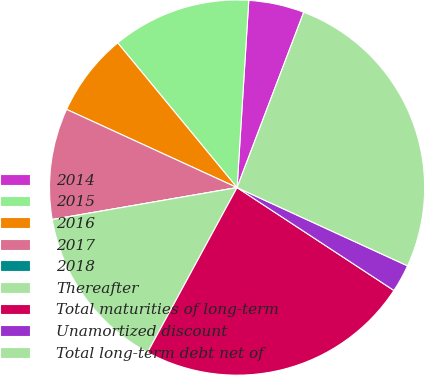Convert chart to OTSL. <chart><loc_0><loc_0><loc_500><loc_500><pie_chart><fcel>2014<fcel>2015<fcel>2016<fcel>2017<fcel>2018<fcel>Thereafter<fcel>Total maturities of long-term<fcel>Unamortized discount<fcel>Total long-term debt net of<nl><fcel>4.79%<fcel>11.97%<fcel>7.18%<fcel>9.57%<fcel>0.0%<fcel>14.36%<fcel>23.68%<fcel>2.39%<fcel>26.07%<nl></chart> 